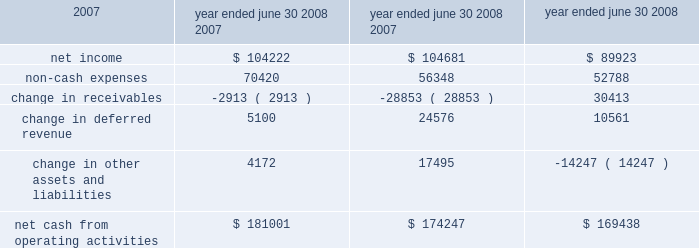L iquidity and capital resources we have historically generated positive cash flow from operations and have generally used funds generated from operations and short-term borrowings on our revolving credit facility to meet capital requirements .
We expect this trend to continue in the future .
The company's cash and cash equivalents decreased to $ 65565 at june 30 , 2008 from $ 88617 at june 30 , 2007 .
The table summarizes net cash from operating activities in the statement of cash flows : year ended june 30 cash provided by operations increased $ 6754 to $ 181001 for the fiscal year ended june 30 , 2008 as compared to $ 174247 for the fiscal year ended june 30 , 2007 .
This increase is primarily attributable to an increase in expenses that do not have a corresponding cash outflow , such as depreciation and amortization , as a percentage of total net income .
Cash used in investing activities for the fiscal year ended june 2008 was $ 102148 and includes payments for acquisitions of $ 48109 , plus $ 1215 in contingent consideration paid on prior years 2019 acquisitions .
During fiscal 2007 , payments for acquisitions totaled $ 34006 , plus $ 5301 paid on earn-outs and other acquisition adjustments .
Capital expenditures for fiscal 2008 were $ 31105 compared to $ 34202 for fiscal 2007 .
Cash used for software development in fiscal 2008 was $ 23736 compared to $ 20743 during the prior year .
Net cash used in financing activities for the current fiscal year was $ 101905 and includes the repurchase of 4200 shares of our common stock for $ 100996 , the payment of dividends of $ 24683 and $ 429 net repayment on our revolving credit facilities .
Cash used in financing activities was partially offset by proceeds of $ 20394 from the exercise of stock options and the sale of common stock and $ 3809 excess tax benefits from stock option exercises .
During fiscal 2007 , net cash used in financing activities included the repurchase of our common stock for $ 98413 and the payment of dividends of $ 21685 .
As in the current year , cash used in fiscal 2007 was partially offset by proceeds from the exercise of stock options and the sale of common stock of $ 29212 , $ 4640 excess tax benefits from stock option exercises and $ 19388 net borrowings on revolving credit facilities .
At june 30 , 2008 , the company had negative working capital of $ 11418 ; however , the largest component of current liabilities was deferred revenue of $ 212375 .
The cash outlay necessary to provide the services related to these deferred revenues is significantly less than this recorded balance .
Therefore , we do not anticipate any liquidity problems to result from this condition .
U.s .
Financial markets and many of the largest u.s .
Financial institutions have recently been shaken by negative developments in the home mortgage industry and the mortgage markets , and particularly the markets for subprime mortgage-backed securities .
While we believe it is too early to predict what effect , if any , these developments may have , we have not experienced any significant issues with our current collec- tion efforts , and we believe that any future impact to our liquidity would be minimized by our access to available lines of credit .
2008 2007 2006 .

What was the percentage change in the cash and cash equivalents at june 30 , 2008 from 2007 .? 
Computations: ((65565 - 88617) / 88617)
Answer: -0.26013. 